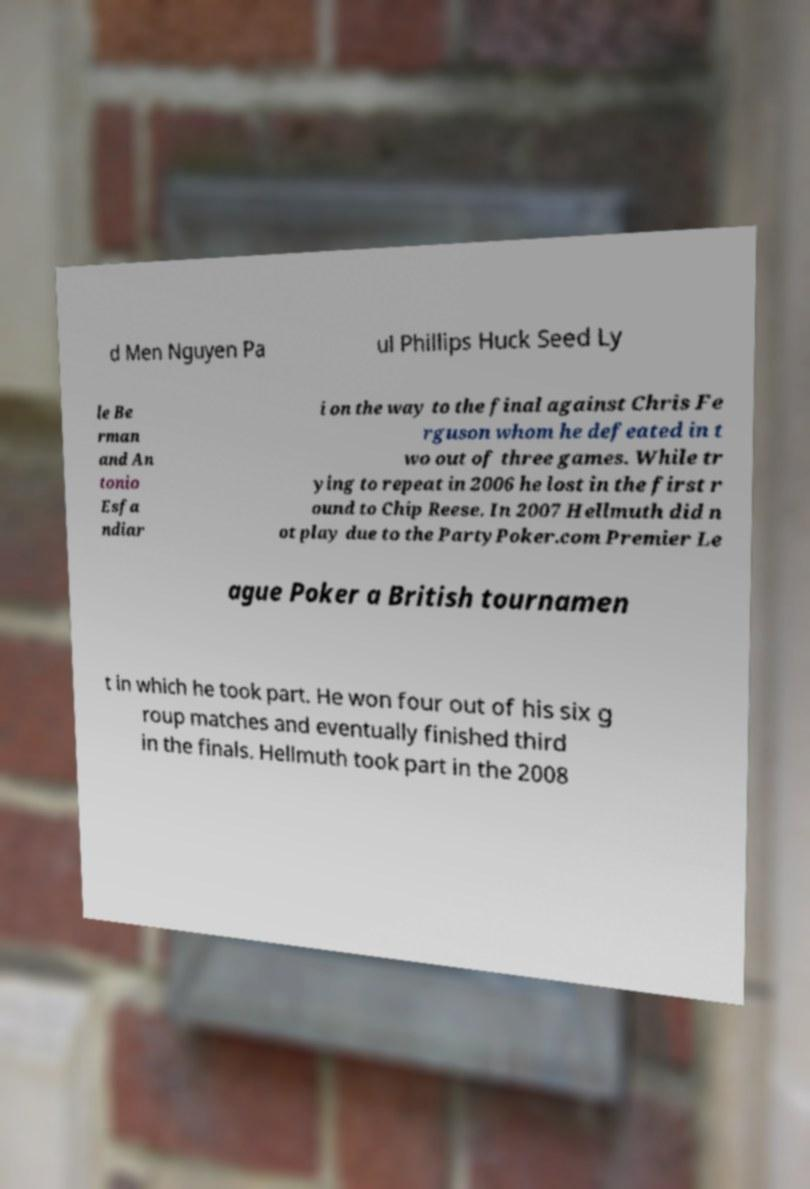For documentation purposes, I need the text within this image transcribed. Could you provide that? d Men Nguyen Pa ul Phillips Huck Seed Ly le Be rman and An tonio Esfa ndiar i on the way to the final against Chris Fe rguson whom he defeated in t wo out of three games. While tr ying to repeat in 2006 he lost in the first r ound to Chip Reese. In 2007 Hellmuth did n ot play due to the PartyPoker.com Premier Le ague Poker a British tournamen t in which he took part. He won four out of his six g roup matches and eventually finished third in the finals. Hellmuth took part in the 2008 